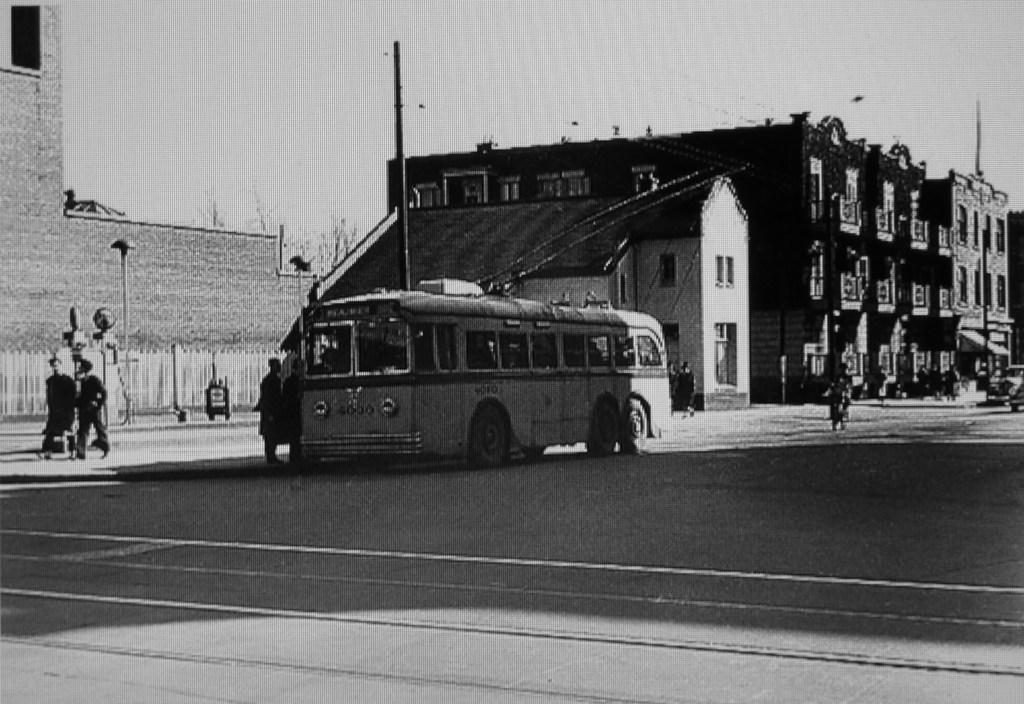How would you summarize this image in a sentence or two? This is a black and white picture. In the middle of the picture, we see the bus. Beside that, we see people are standing. Beside them, we see a pole. On the left side, we see two men are walking on the road. Behind them, we see the poles. There are buildings in the background. On the right side, we see a car and a man riding the bike. At the bottom, we see the road and at the top, we see the sky. 